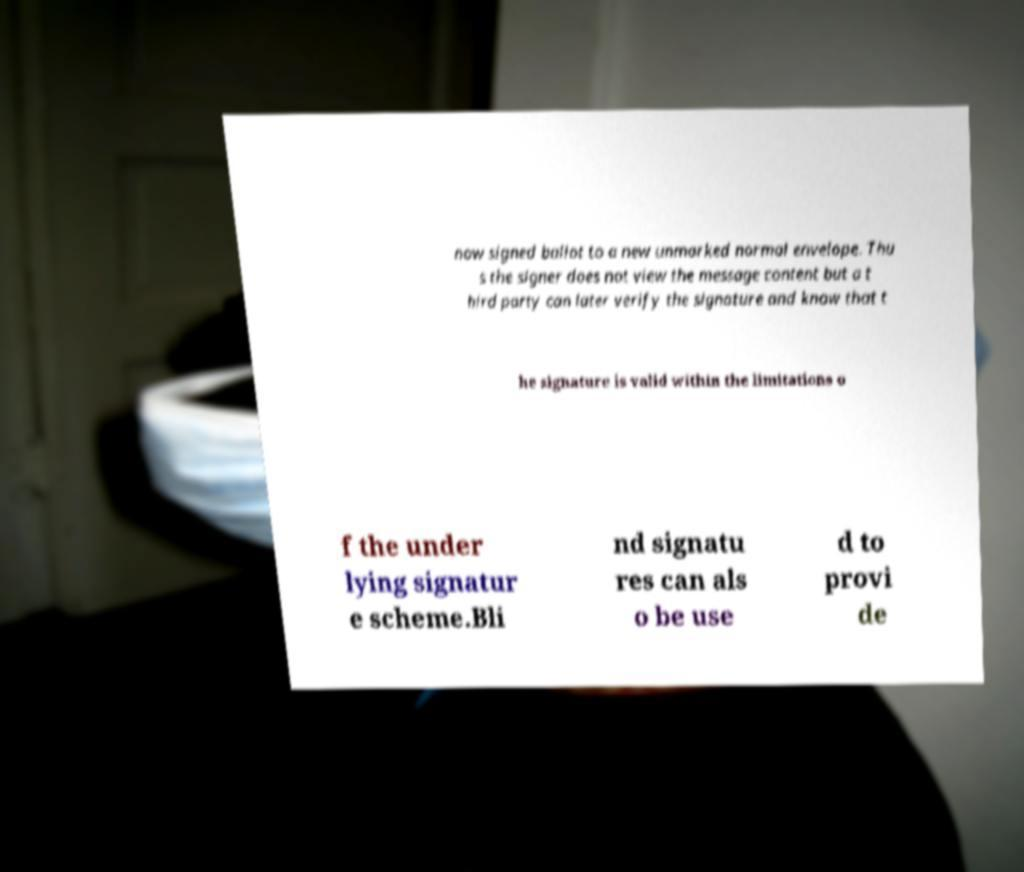I need the written content from this picture converted into text. Can you do that? now signed ballot to a new unmarked normal envelope. Thu s the signer does not view the message content but a t hird party can later verify the signature and know that t he signature is valid within the limitations o f the under lying signatur e scheme.Bli nd signatu res can als o be use d to provi de 